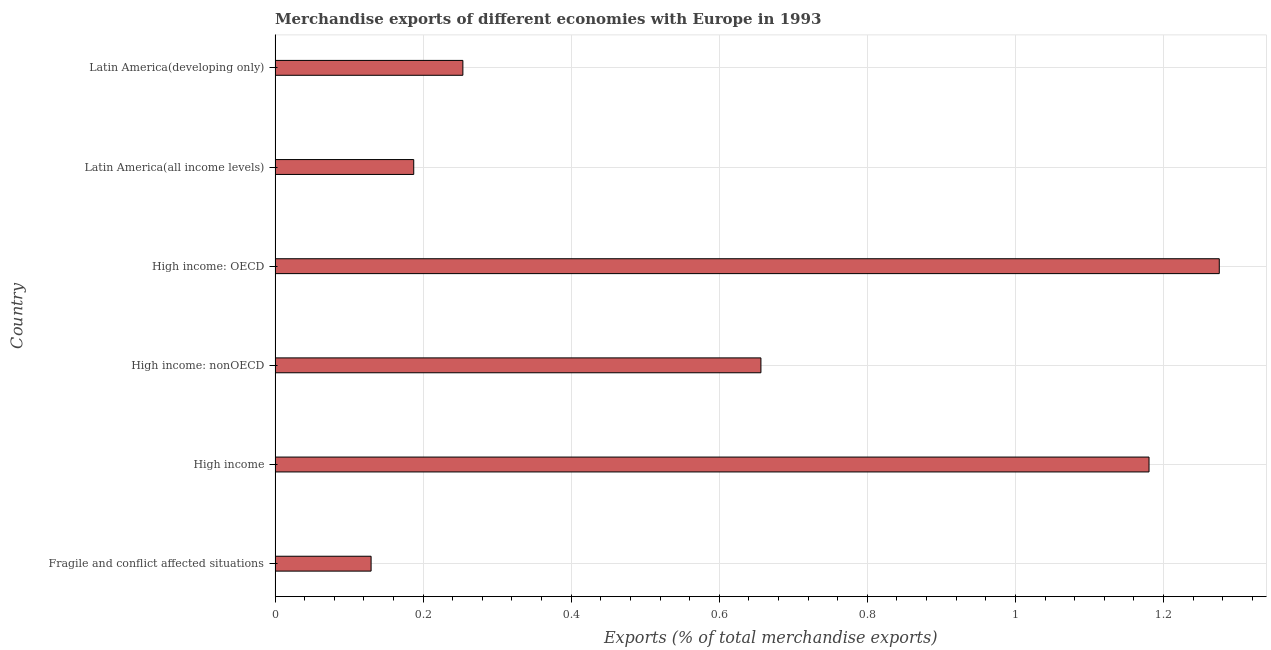Does the graph contain grids?
Give a very brief answer. Yes. What is the title of the graph?
Your answer should be very brief. Merchandise exports of different economies with Europe in 1993. What is the label or title of the X-axis?
Ensure brevity in your answer.  Exports (% of total merchandise exports). What is the label or title of the Y-axis?
Offer a very short reply. Country. What is the merchandise exports in Latin America(all income levels)?
Keep it short and to the point. 0.19. Across all countries, what is the maximum merchandise exports?
Provide a short and direct response. 1.28. Across all countries, what is the minimum merchandise exports?
Your answer should be compact. 0.13. In which country was the merchandise exports maximum?
Provide a succinct answer. High income: OECD. In which country was the merchandise exports minimum?
Ensure brevity in your answer.  Fragile and conflict affected situations. What is the sum of the merchandise exports?
Keep it short and to the point. 3.68. What is the difference between the merchandise exports in Latin America(all income levels) and Latin America(developing only)?
Provide a short and direct response. -0.07. What is the average merchandise exports per country?
Offer a very short reply. 0.61. What is the median merchandise exports?
Keep it short and to the point. 0.45. What is the ratio of the merchandise exports in High income to that in Latin America(all income levels)?
Make the answer very short. 6.3. Is the merchandise exports in Fragile and conflict affected situations less than that in High income: nonOECD?
Provide a succinct answer. Yes. What is the difference between the highest and the second highest merchandise exports?
Offer a terse response. 0.1. What is the difference between the highest and the lowest merchandise exports?
Offer a very short reply. 1.15. In how many countries, is the merchandise exports greater than the average merchandise exports taken over all countries?
Give a very brief answer. 3. How many bars are there?
Your response must be concise. 6. Are all the bars in the graph horizontal?
Ensure brevity in your answer.  Yes. How many countries are there in the graph?
Keep it short and to the point. 6. What is the Exports (% of total merchandise exports) in Fragile and conflict affected situations?
Offer a terse response. 0.13. What is the Exports (% of total merchandise exports) of High income?
Offer a very short reply. 1.18. What is the Exports (% of total merchandise exports) of High income: nonOECD?
Make the answer very short. 0.66. What is the Exports (% of total merchandise exports) in High income: OECD?
Ensure brevity in your answer.  1.28. What is the Exports (% of total merchandise exports) of Latin America(all income levels)?
Keep it short and to the point. 0.19. What is the Exports (% of total merchandise exports) in Latin America(developing only)?
Provide a succinct answer. 0.25. What is the difference between the Exports (% of total merchandise exports) in Fragile and conflict affected situations and High income?
Offer a terse response. -1.05. What is the difference between the Exports (% of total merchandise exports) in Fragile and conflict affected situations and High income: nonOECD?
Ensure brevity in your answer.  -0.53. What is the difference between the Exports (% of total merchandise exports) in Fragile and conflict affected situations and High income: OECD?
Ensure brevity in your answer.  -1.15. What is the difference between the Exports (% of total merchandise exports) in Fragile and conflict affected situations and Latin America(all income levels)?
Keep it short and to the point. -0.06. What is the difference between the Exports (% of total merchandise exports) in Fragile and conflict affected situations and Latin America(developing only)?
Your answer should be very brief. -0.12. What is the difference between the Exports (% of total merchandise exports) in High income and High income: nonOECD?
Keep it short and to the point. 0.52. What is the difference between the Exports (% of total merchandise exports) in High income and High income: OECD?
Make the answer very short. -0.09. What is the difference between the Exports (% of total merchandise exports) in High income and Latin America(developing only)?
Offer a terse response. 0.93. What is the difference between the Exports (% of total merchandise exports) in High income: nonOECD and High income: OECD?
Make the answer very short. -0.62. What is the difference between the Exports (% of total merchandise exports) in High income: nonOECD and Latin America(all income levels)?
Give a very brief answer. 0.47. What is the difference between the Exports (% of total merchandise exports) in High income: nonOECD and Latin America(developing only)?
Offer a terse response. 0.4. What is the difference between the Exports (% of total merchandise exports) in High income: OECD and Latin America(all income levels)?
Make the answer very short. 1.09. What is the difference between the Exports (% of total merchandise exports) in High income: OECD and Latin America(developing only)?
Provide a succinct answer. 1.02. What is the difference between the Exports (% of total merchandise exports) in Latin America(all income levels) and Latin America(developing only)?
Provide a succinct answer. -0.07. What is the ratio of the Exports (% of total merchandise exports) in Fragile and conflict affected situations to that in High income?
Give a very brief answer. 0.11. What is the ratio of the Exports (% of total merchandise exports) in Fragile and conflict affected situations to that in High income: nonOECD?
Your answer should be very brief. 0.2. What is the ratio of the Exports (% of total merchandise exports) in Fragile and conflict affected situations to that in High income: OECD?
Offer a terse response. 0.1. What is the ratio of the Exports (% of total merchandise exports) in Fragile and conflict affected situations to that in Latin America(all income levels)?
Ensure brevity in your answer.  0.69. What is the ratio of the Exports (% of total merchandise exports) in Fragile and conflict affected situations to that in Latin America(developing only)?
Ensure brevity in your answer.  0.51. What is the ratio of the Exports (% of total merchandise exports) in High income to that in High income: nonOECD?
Keep it short and to the point. 1.8. What is the ratio of the Exports (% of total merchandise exports) in High income to that in High income: OECD?
Your answer should be very brief. 0.93. What is the ratio of the Exports (% of total merchandise exports) in High income to that in Latin America(all income levels)?
Offer a terse response. 6.3. What is the ratio of the Exports (% of total merchandise exports) in High income to that in Latin America(developing only)?
Keep it short and to the point. 4.65. What is the ratio of the Exports (% of total merchandise exports) in High income: nonOECD to that in High income: OECD?
Offer a very short reply. 0.52. What is the ratio of the Exports (% of total merchandise exports) in High income: nonOECD to that in Latin America(all income levels)?
Provide a short and direct response. 3.5. What is the ratio of the Exports (% of total merchandise exports) in High income: nonOECD to that in Latin America(developing only)?
Provide a short and direct response. 2.59. What is the ratio of the Exports (% of total merchandise exports) in High income: OECD to that in Latin America(all income levels)?
Offer a very short reply. 6.81. What is the ratio of the Exports (% of total merchandise exports) in High income: OECD to that in Latin America(developing only)?
Offer a terse response. 5.03. What is the ratio of the Exports (% of total merchandise exports) in Latin America(all income levels) to that in Latin America(developing only)?
Give a very brief answer. 0.74. 